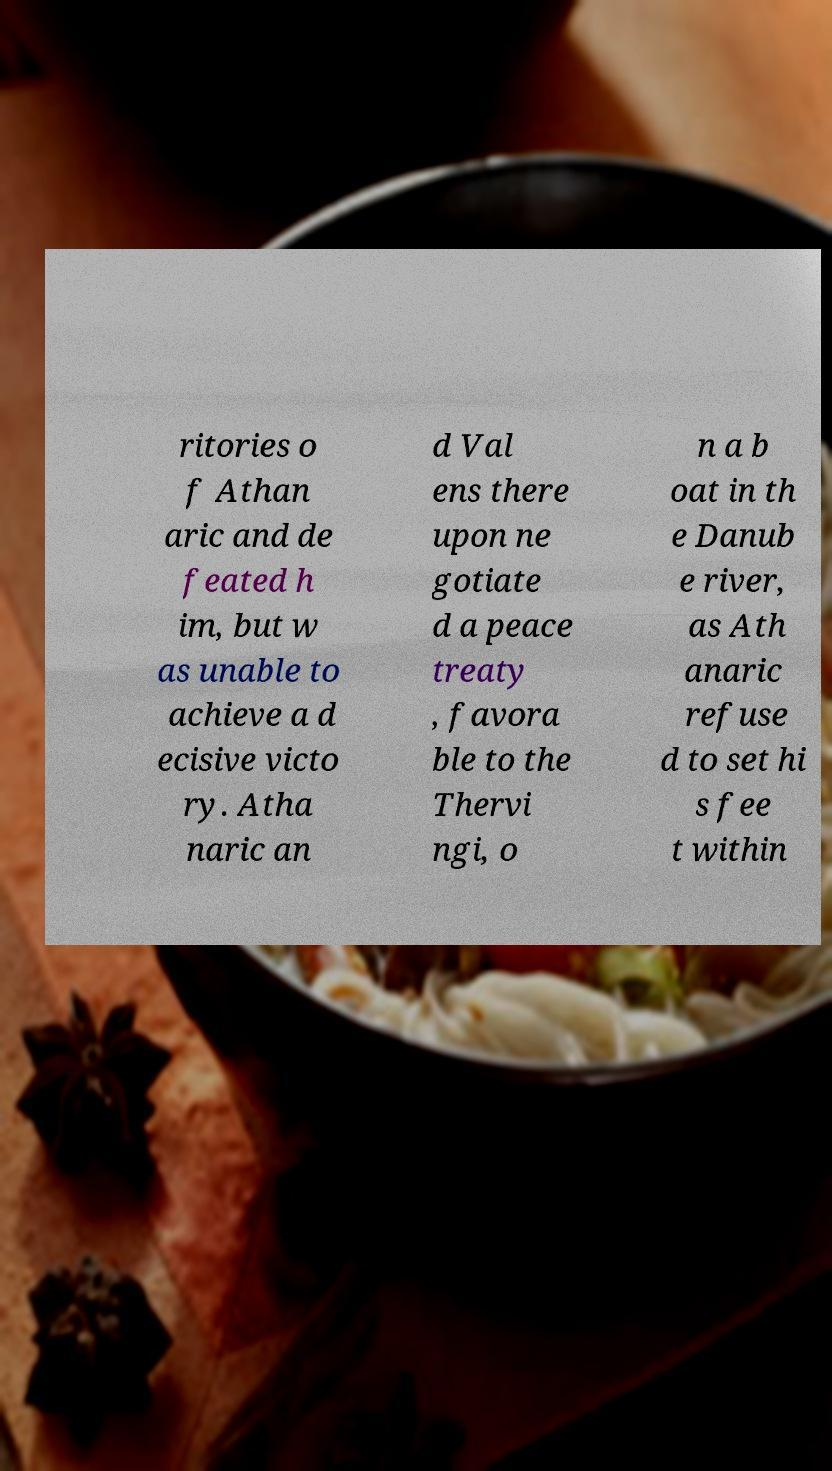Can you read and provide the text displayed in the image?This photo seems to have some interesting text. Can you extract and type it out for me? ritories o f Athan aric and de feated h im, but w as unable to achieve a d ecisive victo ry. Atha naric an d Val ens there upon ne gotiate d a peace treaty , favora ble to the Thervi ngi, o n a b oat in th e Danub e river, as Ath anaric refuse d to set hi s fee t within 